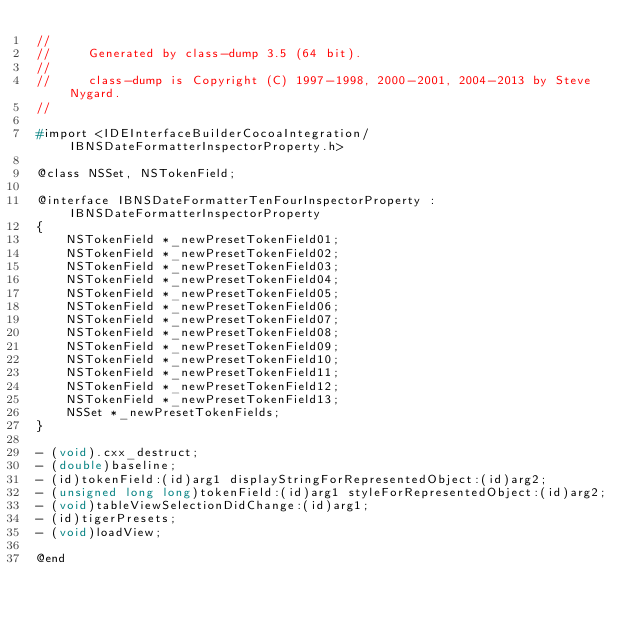Convert code to text. <code><loc_0><loc_0><loc_500><loc_500><_C_>//
//     Generated by class-dump 3.5 (64 bit).
//
//     class-dump is Copyright (C) 1997-1998, 2000-2001, 2004-2013 by Steve Nygard.
//

#import <IDEInterfaceBuilderCocoaIntegration/IBNSDateFormatterInspectorProperty.h>

@class NSSet, NSTokenField;

@interface IBNSDateFormatterTenFourInspectorProperty : IBNSDateFormatterInspectorProperty
{
    NSTokenField *_newPresetTokenField01;
    NSTokenField *_newPresetTokenField02;
    NSTokenField *_newPresetTokenField03;
    NSTokenField *_newPresetTokenField04;
    NSTokenField *_newPresetTokenField05;
    NSTokenField *_newPresetTokenField06;
    NSTokenField *_newPresetTokenField07;
    NSTokenField *_newPresetTokenField08;
    NSTokenField *_newPresetTokenField09;
    NSTokenField *_newPresetTokenField10;
    NSTokenField *_newPresetTokenField11;
    NSTokenField *_newPresetTokenField12;
    NSTokenField *_newPresetTokenField13;
    NSSet *_newPresetTokenFields;
}

- (void).cxx_destruct;
- (double)baseline;
- (id)tokenField:(id)arg1 displayStringForRepresentedObject:(id)arg2;
- (unsigned long long)tokenField:(id)arg1 styleForRepresentedObject:(id)arg2;
- (void)tableViewSelectionDidChange:(id)arg1;
- (id)tigerPresets;
- (void)loadView;

@end

</code> 